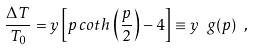<formula> <loc_0><loc_0><loc_500><loc_500>\frac { \Delta T } { T _ { 0 } } = y \left [ p \, c o t h \, \left ( \frac { p } { 2 } \right ) - 4 \right ] \equiv y \ g ( p ) \ ,</formula> 